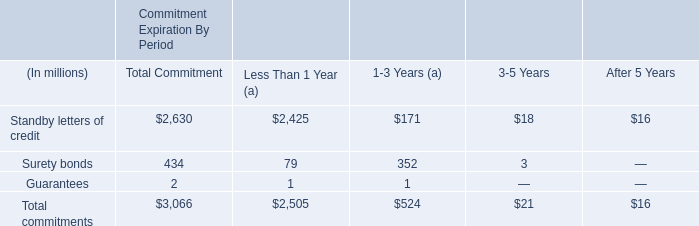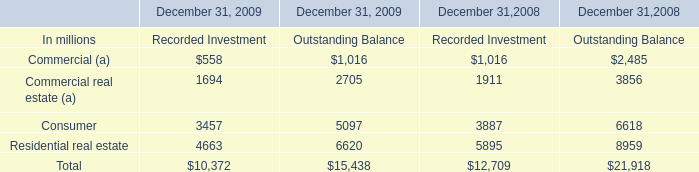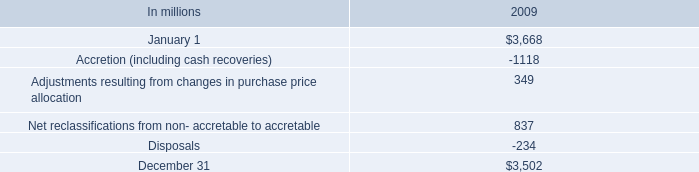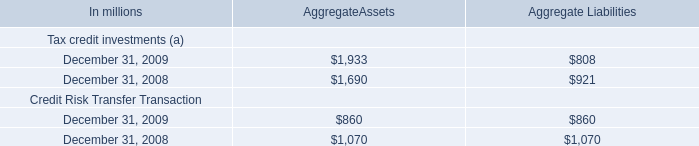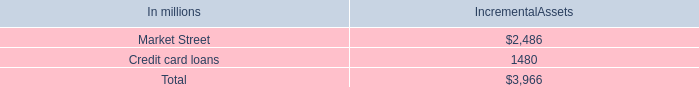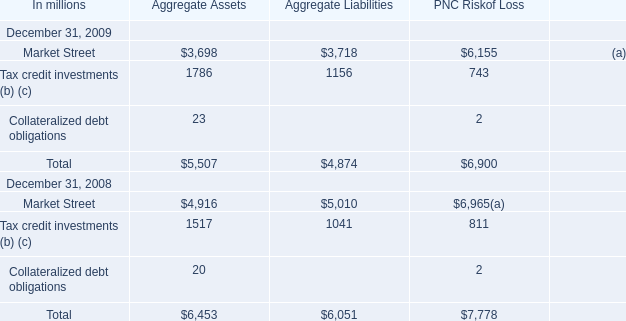What will Collateralized debt obligations reach in 2010 if it continues to grow at its current rate? (in million) 
Computations: ((((23 - 20) / 20) + 1) * 23)
Answer: 26.45. 